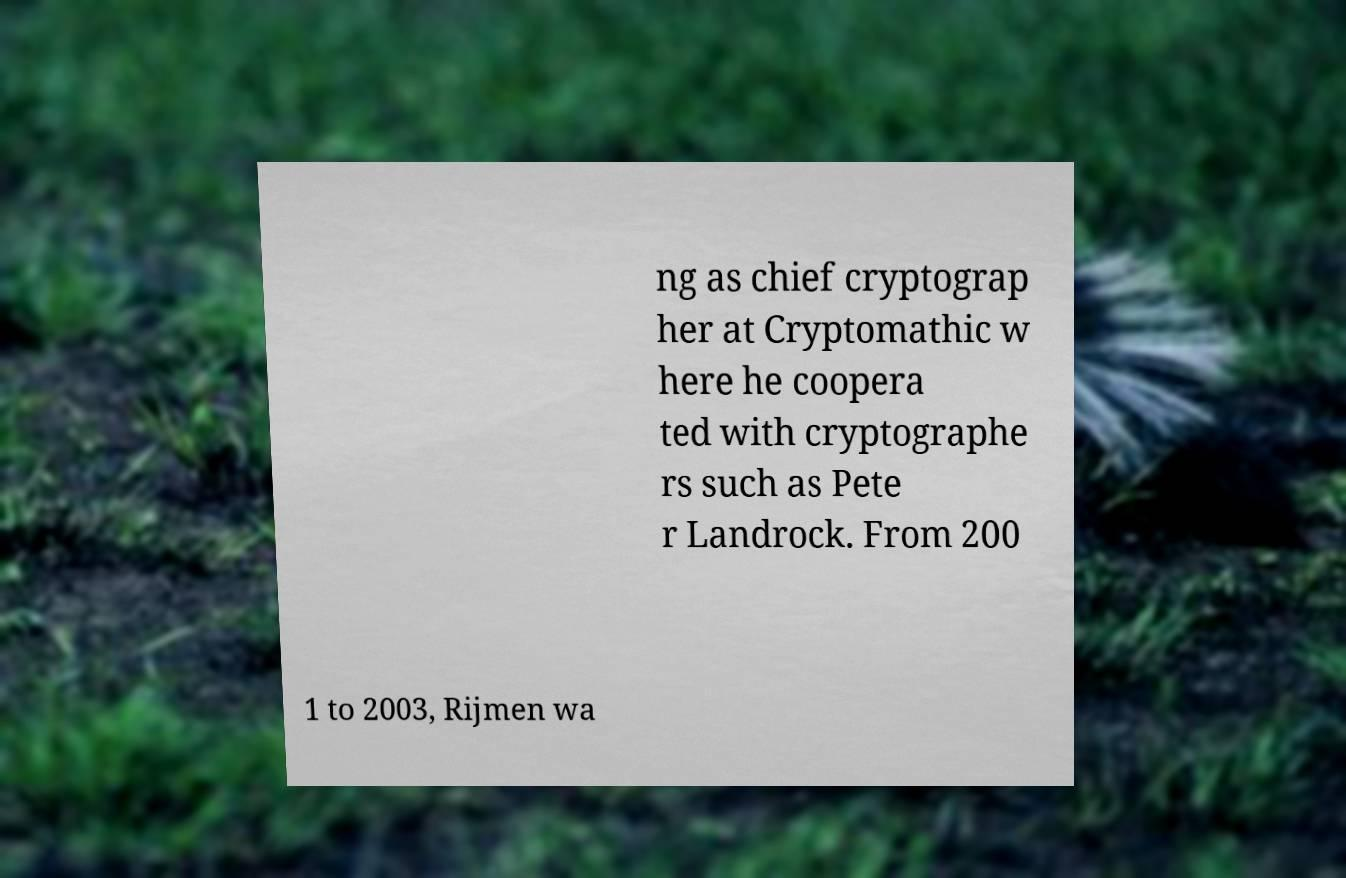There's text embedded in this image that I need extracted. Can you transcribe it verbatim? ng as chief cryptograp her at Cryptomathic w here he coopera ted with cryptographe rs such as Pete r Landrock. From 200 1 to 2003, Rijmen wa 